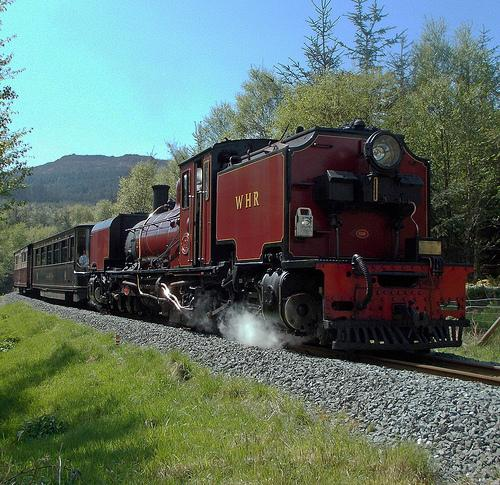Describe the image as if you were explaining it to an alien who has never seen a train. A large wheeled metal machine known as a train is moving along a set path. It's red in color, emitting smoke, and surrounded by various elements of our planet, such as trees, rocks, grass, and mountains. Imagine you're a character in the image. Write a thought you would have. As the locomotive makes its steady, rhythmic journey, I'm captivated by the symphony of natural beauty that surrounds me. Tell me what you see in this picture in a poetic way. In the embrace of green trees, a rustic red locomotive journeys through a rocky terrain, enveloped by a blue sky stretching far above the distant mountains. Write an attention-catching headline for a news article about the image. Iconic Red Train Ignites Nostalgia As It Chugs Through Scenic Landscape! Express the scene in the image as if it were a postcard message. Greetings from the countryside! This charming old red locomotive I saw today reminds me of a bygone era. Wish you were here! Provide a brief summary of the key elements in this visual. A red train with yellow lettering moves along tracks, surrounded by rocky gray gravel, green grass, a blue sky, and mountains in the distance. What comes to mind when you see this image? An old, red train chugging steadily along, with its trails of smoke mingling against the backdrop of clear, blue skies and distant mountains. Describe the setting of the image as if you were writing the opening scene of a novel. Once a grand sight against the blue sky and soaring mountains, the old red train, now marred by rust and age, persevered on through the verdant surroundings with a touch of grace. Write a tweet about the image. Just witnessed a beautiful slice of #nostalgia - an old red #train chugging along the tracks, surrounded by stunning #nature! 🚂🌳🌄 #travel #railway Write an advertisement for the scenic experience in the image. Experience the voyage of a lifetime aboard a historic locomotive! Journey through lush landscapes, feel the thrilling momentum, and create memories that last forever on this majestic red train. 